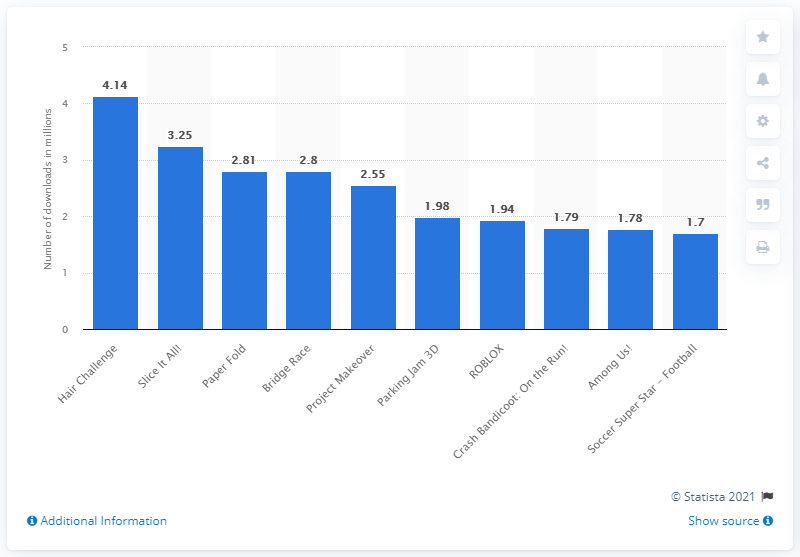Point out several critical features in this image. Slice it All! received a total of 3.25 downloads. In April 2021, the Hair Challenge app received 4,140 downloads from iPhone users. In April 2021, the most downloaded game for iPhone was "Hair Challenge. 